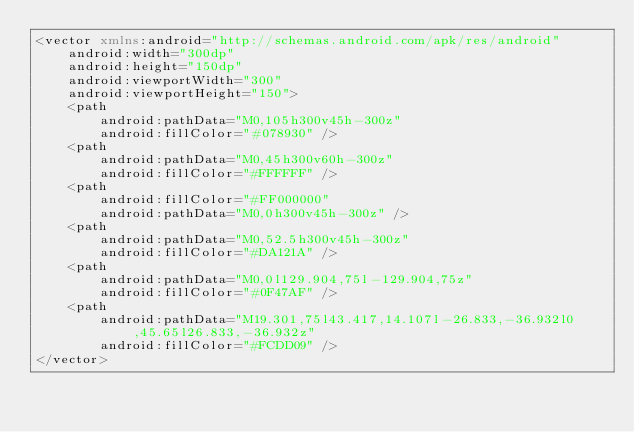Convert code to text. <code><loc_0><loc_0><loc_500><loc_500><_XML_><vector xmlns:android="http://schemas.android.com/apk/res/android"
    android:width="300dp"
    android:height="150dp"
    android:viewportWidth="300"
    android:viewportHeight="150">
    <path
        android:pathData="M0,105h300v45h-300z"
        android:fillColor="#078930" />
    <path
        android:pathData="M0,45h300v60h-300z"
        android:fillColor="#FFFFFF" />
    <path
        android:fillColor="#FF000000"
        android:pathData="M0,0h300v45h-300z" />
    <path
        android:pathData="M0,52.5h300v45h-300z"
        android:fillColor="#DA121A" />
    <path
        android:pathData="M0,0l129.904,75l-129.904,75z"
        android:fillColor="#0F47AF" />
    <path
        android:pathData="M19.301,75l43.417,14.107l-26.833,-36.932l0,45.65l26.833,-36.932z"
        android:fillColor="#FCDD09" />
</vector>
</code> 